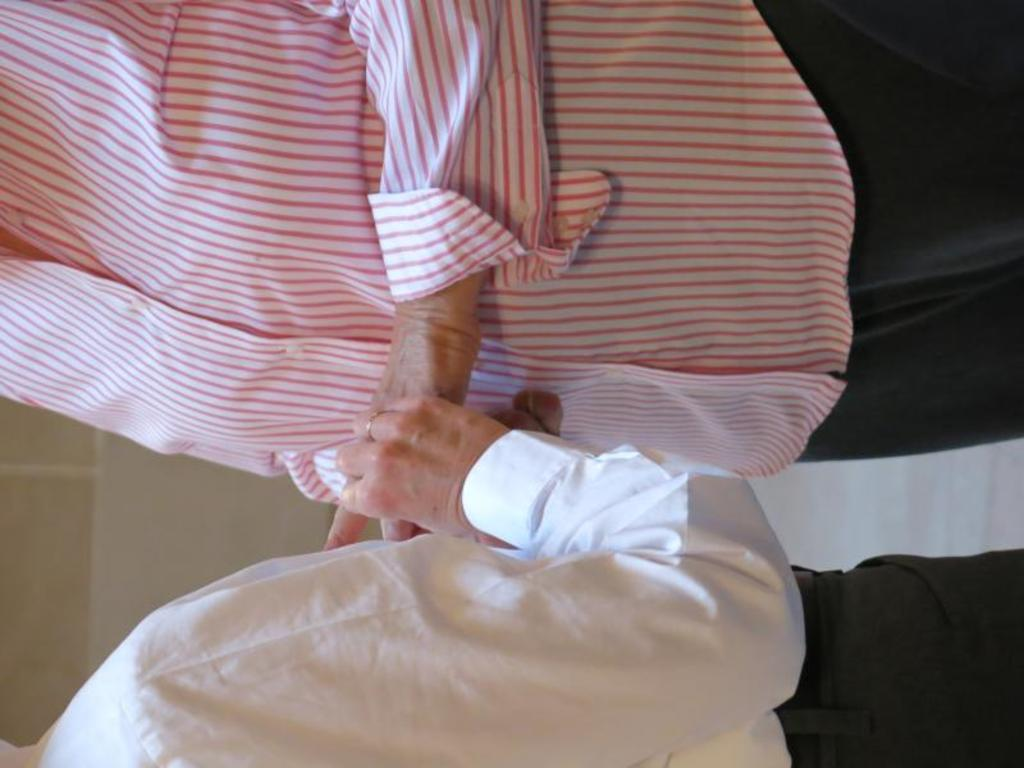How many people are present in the image? The number of people in the image cannot be determined from the provided fact. What type of tools does the carpenter use in the image? There is no carpenter present in the image, so it is not possible to answer that question. 